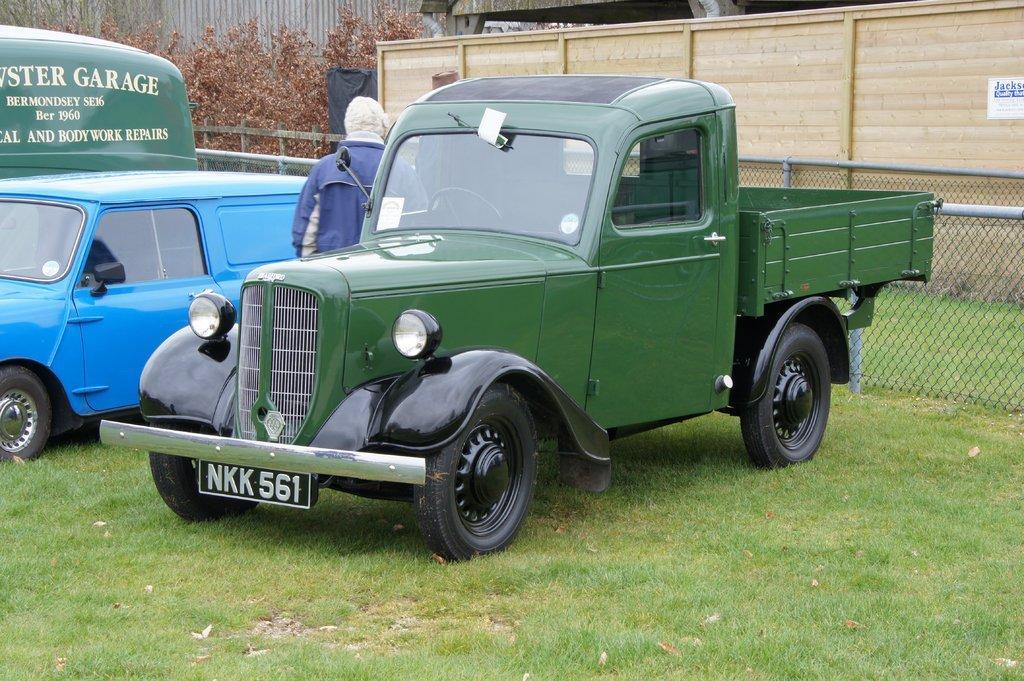How would you summarize this image in a sentence or two? In this picture there are vehicles. There is a person standing behind the vehicle. At the back there is a building and there is a fence and there are trees and there is a poster on the wall. At the bottom there is grass. 